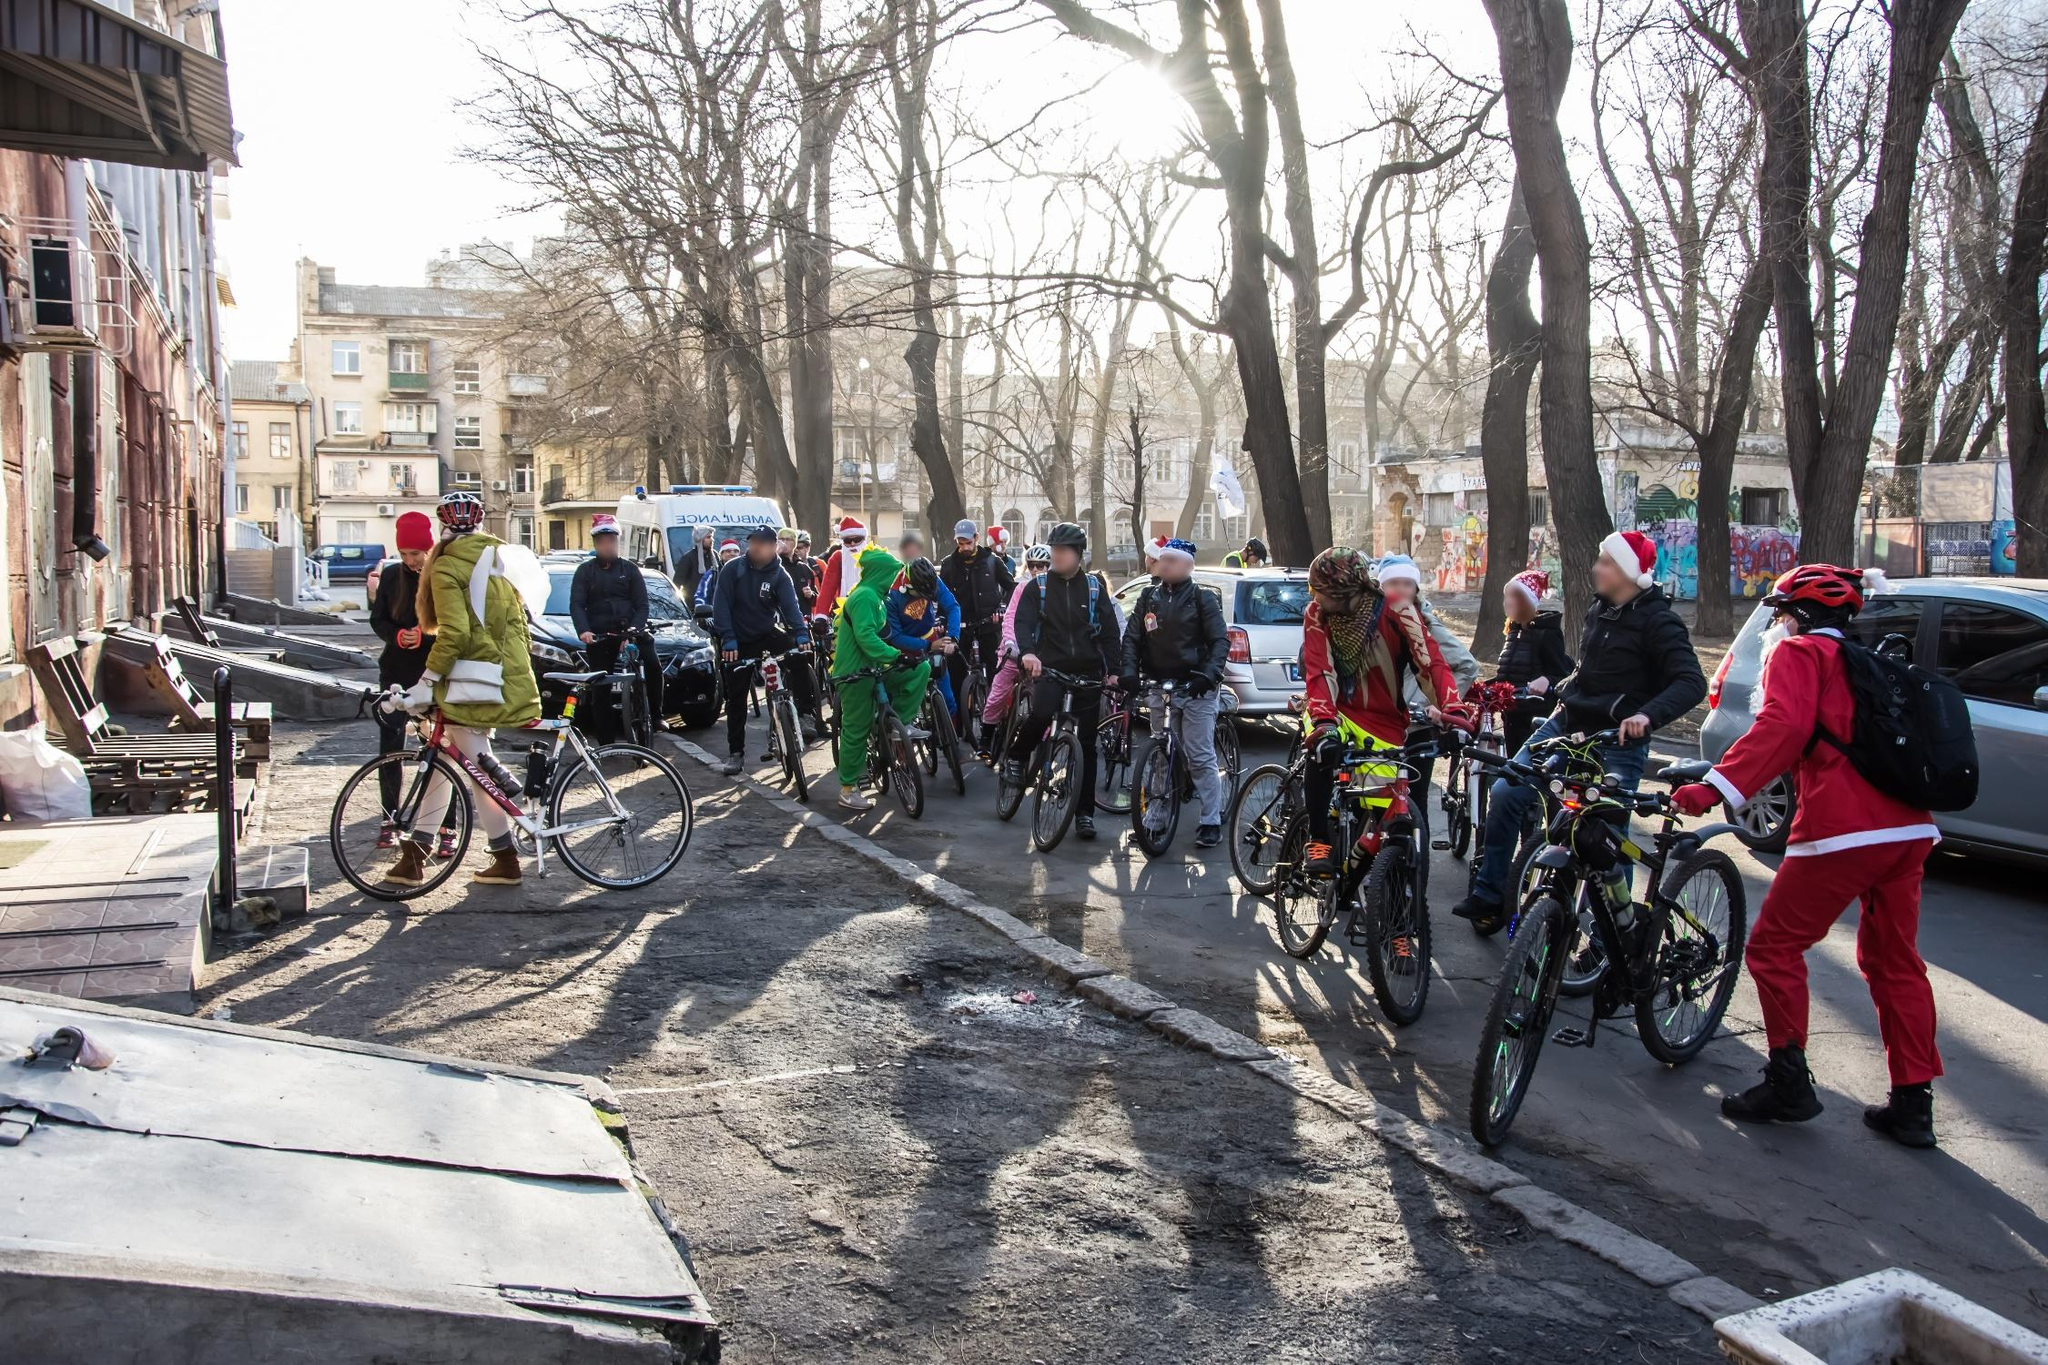Imagine if the characters in the image had superpowers. Describe an adventurous scenario involving their powers. Imagine the characters in the image as festive superheroes, each with unique winter-themed powers, embarking on a daring quest to save the city. One cyclist dressed in green can turn into Evergreen, capable of transforming barren trees into lush, festively decorated evergreens with a touch. Another, wearing a Santa outfit, becomes Frostbite, able to create icy paths to aid in quickly traversing the city. Together, they discover a plot by the villain, Heat Miser, who plans to melt all the snow and stop Christmas celebrations. As they pedal through the city, they use their powers to thwart Heat Miser's plans, ensuring neighborhoods are blanketed in festive snow and illuminated by the glow of Evergreen's magical trees. Their journey involves heart-pounding chases, where Frostbite crafts icy ramps and slides, making dramatic escapes and turning the city streets into a winter wonderland, finally celebrating their success with the community in a grand festive feast. The image transforms into a wintry hero’s tale of camaraderie, festive spirit, and adventure. 